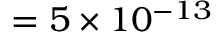Convert formula to latex. <formula><loc_0><loc_0><loc_500><loc_500>= 5 \times 1 0 ^ { - 1 3 }</formula> 